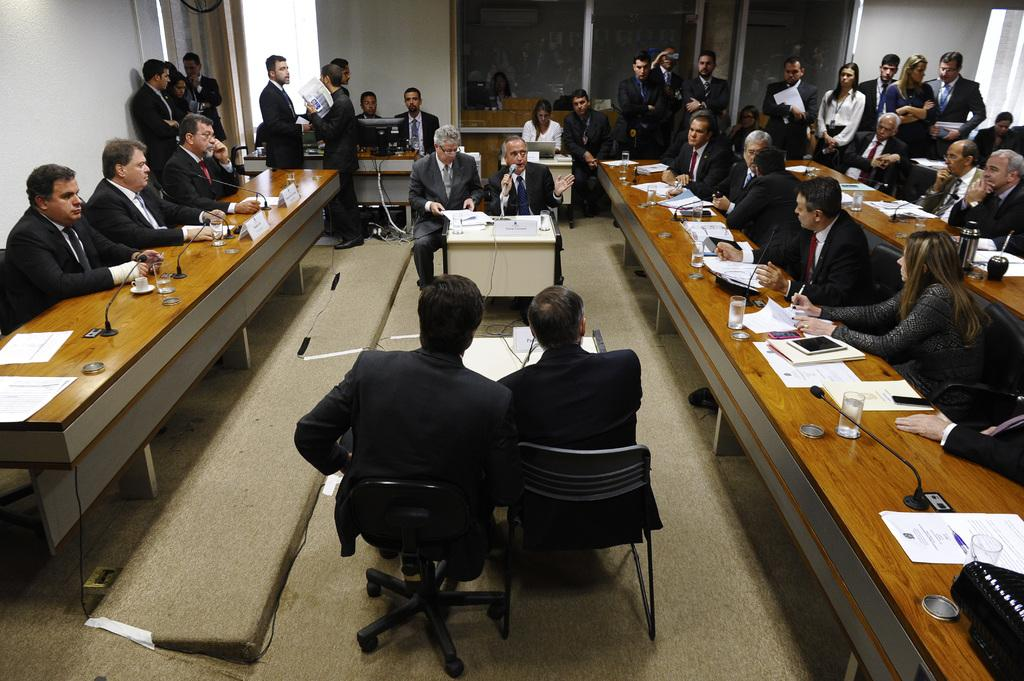What are the people in the image doing? The people in the image are sitting on chairs. What objects can be seen on the tables in the image? There are microphones, glasses, and papers on the tables in the image. What type of furniture is present in the image? There are chairs and tables in the image. What can be seen on the walls in the image? There are walls visible in the image. Is there a plant involved in a fight in the image? There is no plant or fight present in the image. Is there a birthday celebration taking place in the image? There is no indication of a birthday celebration in the image. 